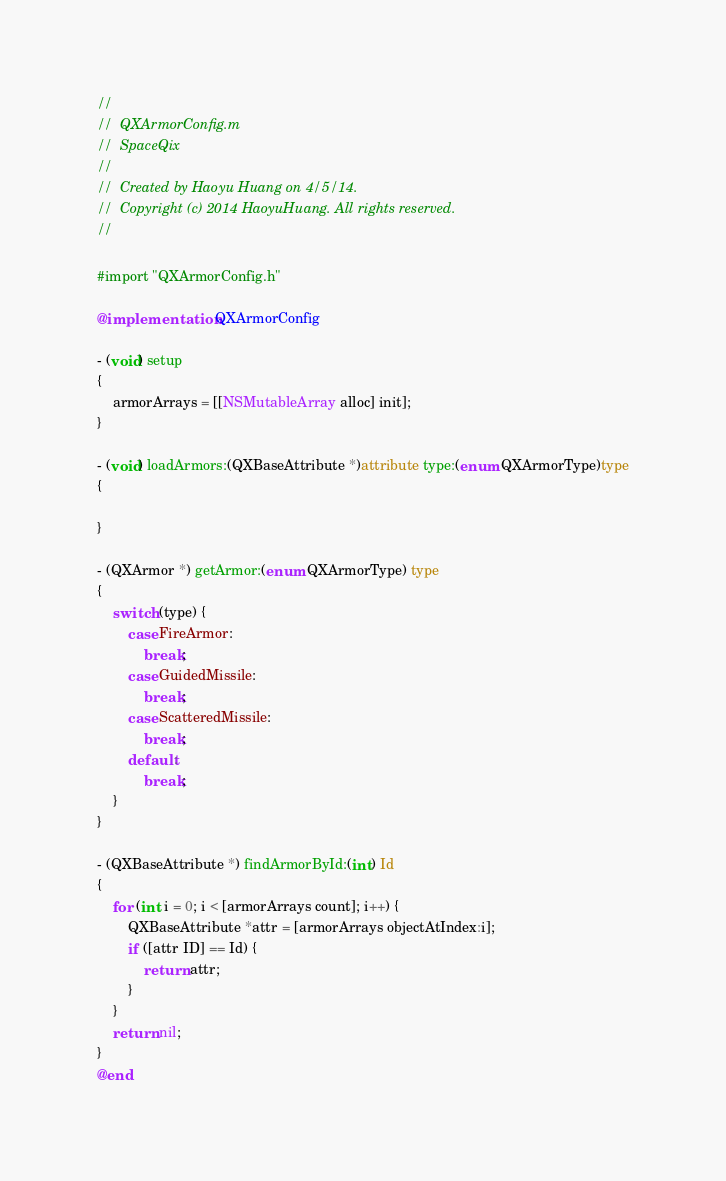Convert code to text. <code><loc_0><loc_0><loc_500><loc_500><_ObjectiveC_>//
//  QXArmorConfig.m
//  SpaceQix
//
//  Created by Haoyu Huang on 4/5/14.
//  Copyright (c) 2014 HaoyuHuang. All rights reserved.
//

#import "QXArmorConfig.h"

@implementation QXArmorConfig

- (void) setup
{
    armorArrays = [[NSMutableArray alloc] init];
}

- (void) loadArmors:(QXBaseAttribute *)attribute type:(enum QXArmorType)type
{
    
}

- (QXArmor *) getArmor:(enum QXArmorType) type
{
    switch (type) {
        case FireArmor:
            break;
        case GuidedMissile:
            break;
        case ScatteredMissile:
            break;
        default:
            break;
    }
}

- (QXBaseAttribute *) findArmorById:(int) Id
{
    for (int i = 0; i < [armorArrays count]; i++) {
        QXBaseAttribute *attr = [armorArrays objectAtIndex:i];
        if ([attr ID] == Id) {
            return attr;
        }
    }
    return nil;
}
@end
</code> 